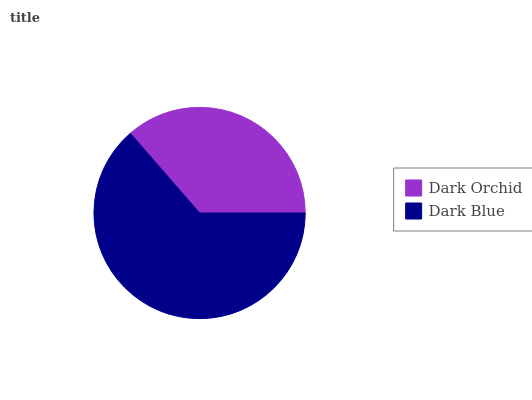Is Dark Orchid the minimum?
Answer yes or no. Yes. Is Dark Blue the maximum?
Answer yes or no. Yes. Is Dark Blue the minimum?
Answer yes or no. No. Is Dark Blue greater than Dark Orchid?
Answer yes or no. Yes. Is Dark Orchid less than Dark Blue?
Answer yes or no. Yes. Is Dark Orchid greater than Dark Blue?
Answer yes or no. No. Is Dark Blue less than Dark Orchid?
Answer yes or no. No. Is Dark Blue the high median?
Answer yes or no. Yes. Is Dark Orchid the low median?
Answer yes or no. Yes. Is Dark Orchid the high median?
Answer yes or no. No. Is Dark Blue the low median?
Answer yes or no. No. 